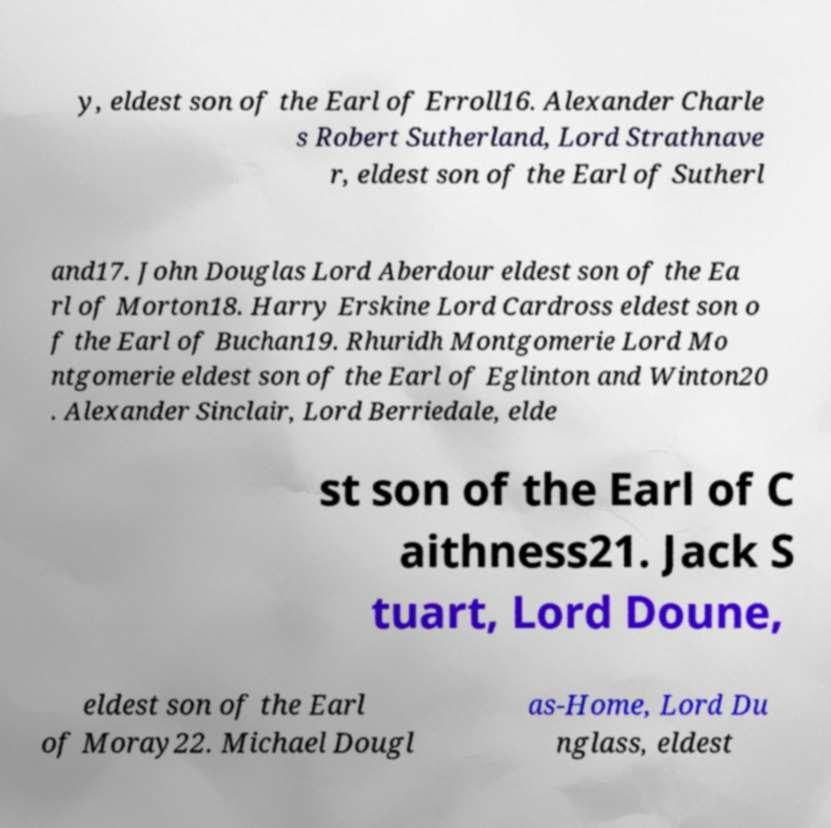Please read and relay the text visible in this image. What does it say? y, eldest son of the Earl of Erroll16. Alexander Charle s Robert Sutherland, Lord Strathnave r, eldest son of the Earl of Sutherl and17. John Douglas Lord Aberdour eldest son of the Ea rl of Morton18. Harry Erskine Lord Cardross eldest son o f the Earl of Buchan19. Rhuridh Montgomerie Lord Mo ntgomerie eldest son of the Earl of Eglinton and Winton20 . Alexander Sinclair, Lord Berriedale, elde st son of the Earl of C aithness21. Jack S tuart, Lord Doune, eldest son of the Earl of Moray22. Michael Dougl as-Home, Lord Du nglass, eldest 